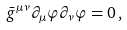Convert formula to latex. <formula><loc_0><loc_0><loc_500><loc_500>\bar { g } ^ { \mu \nu } \partial _ { \mu } \varphi \partial _ { \nu } \varphi = 0 \, ,</formula> 